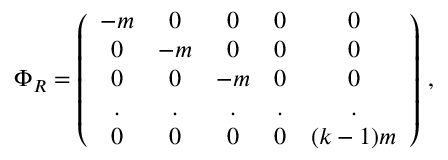Convert formula to latex. <formula><loc_0><loc_0><loc_500><loc_500>\Phi _ { R } = \left ( \begin{array} { c c c c c } { - m } & { 0 } & { 0 } & { 0 } & { 0 } \\ { 0 } & { - m } & { 0 } & { 0 } & { 0 } \\ { 0 } & { 0 } & { - m } & { 0 } & { 0 } \\ { . } & { . } & { . } & { . } & { . } \\ { 0 } & { 0 } & { 0 } & { 0 } & { ( k - 1 ) m } \end{array} \right ) \, ,</formula> 